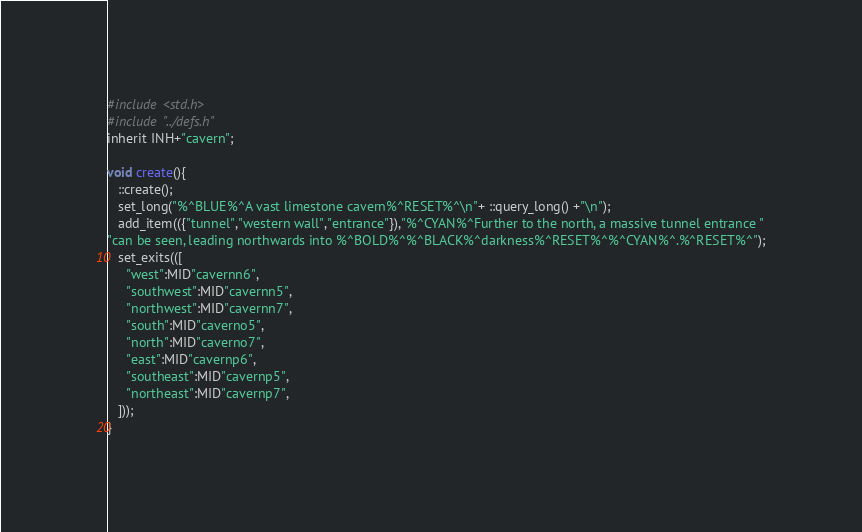<code> <loc_0><loc_0><loc_500><loc_500><_C_>#include <std.h>
#include "../defs.h"
inherit INH+"cavern";

void create(){ 
   ::create();
   set_long("%^BLUE%^A vast limestone cavern%^RESET%^\n"+ ::query_long() +"\n");
   add_item(({"tunnel","western wall","entrance"}),"%^CYAN%^Further to the north, a massive tunnel entrance "
"can be seen, leading northwards into %^BOLD%^%^BLACK%^darkness%^RESET%^%^CYAN%^.%^RESET%^");
   set_exits(([
     "west":MID"cavernn6",
     "southwest":MID"cavernn5",
     "northwest":MID"cavernn7",
     "south":MID"caverno5",
     "north":MID"caverno7",
     "east":MID"cavernp6",
     "southeast":MID"cavernp5",
     "northeast":MID"cavernp7",
   ]));
}
</code> 